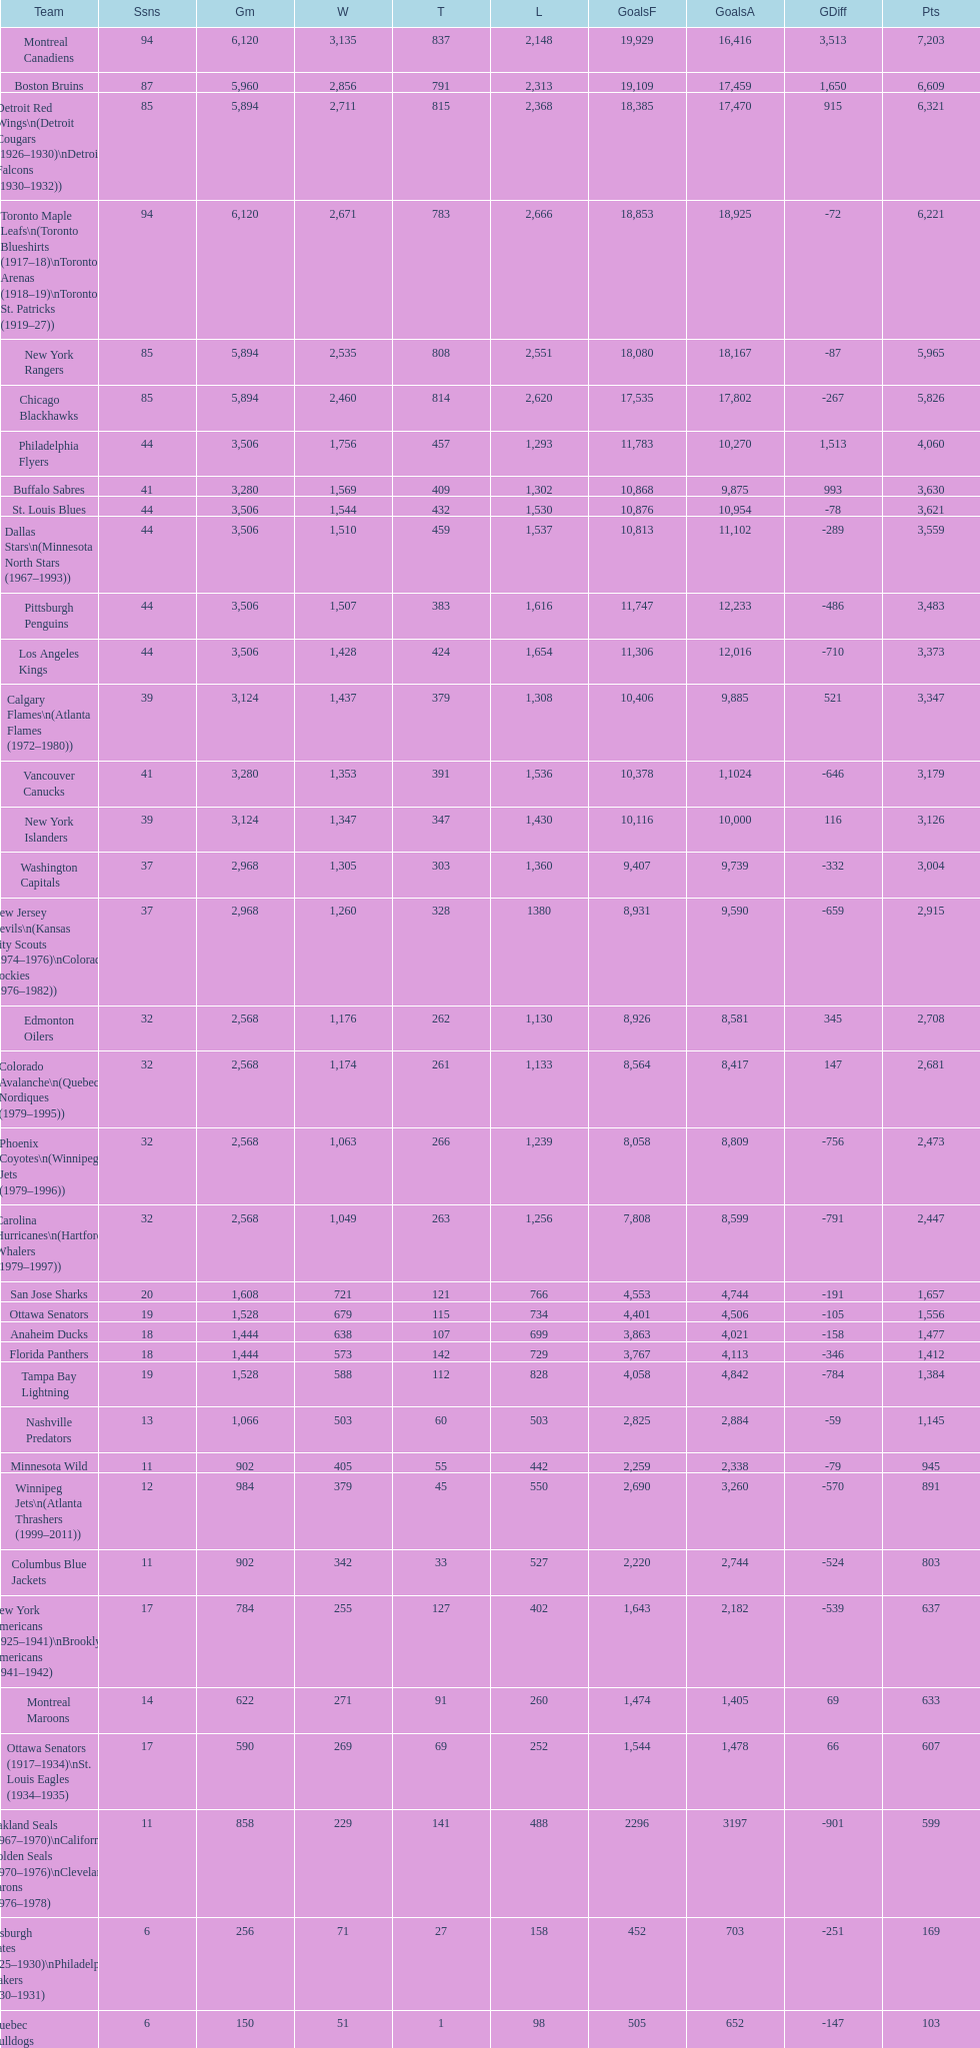How many teams have won more than 1,500 games? 11. 